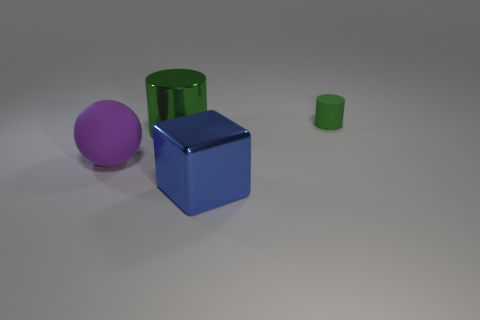Add 3 yellow balls. How many objects exist? 7 Subtract all cubes. How many objects are left? 3 Subtract 1 purple spheres. How many objects are left? 3 Subtract all purple spheres. Subtract all green objects. How many objects are left? 1 Add 2 green objects. How many green objects are left? 4 Add 1 large yellow shiny cylinders. How many large yellow shiny cylinders exist? 1 